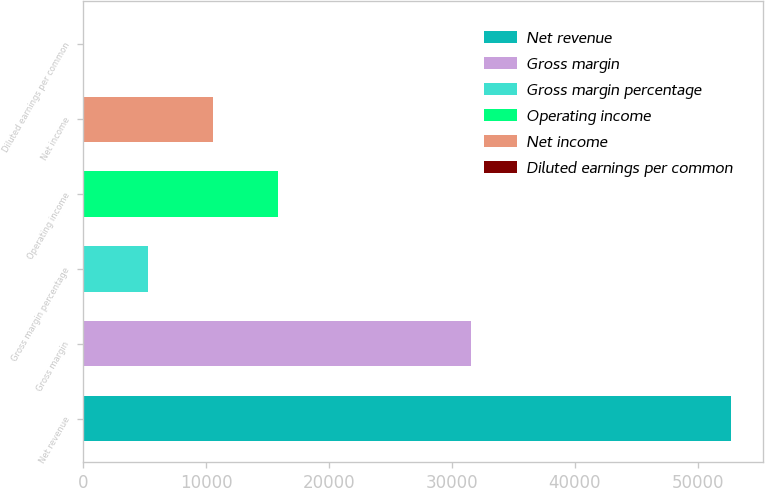<chart> <loc_0><loc_0><loc_500><loc_500><bar_chart><fcel>Net revenue<fcel>Gross margin<fcel>Gross margin percentage<fcel>Operating income<fcel>Net income<fcel>Diluted earnings per common<nl><fcel>52708<fcel>31521<fcel>5272.5<fcel>15813.7<fcel>10543.1<fcel>1.89<nl></chart> 